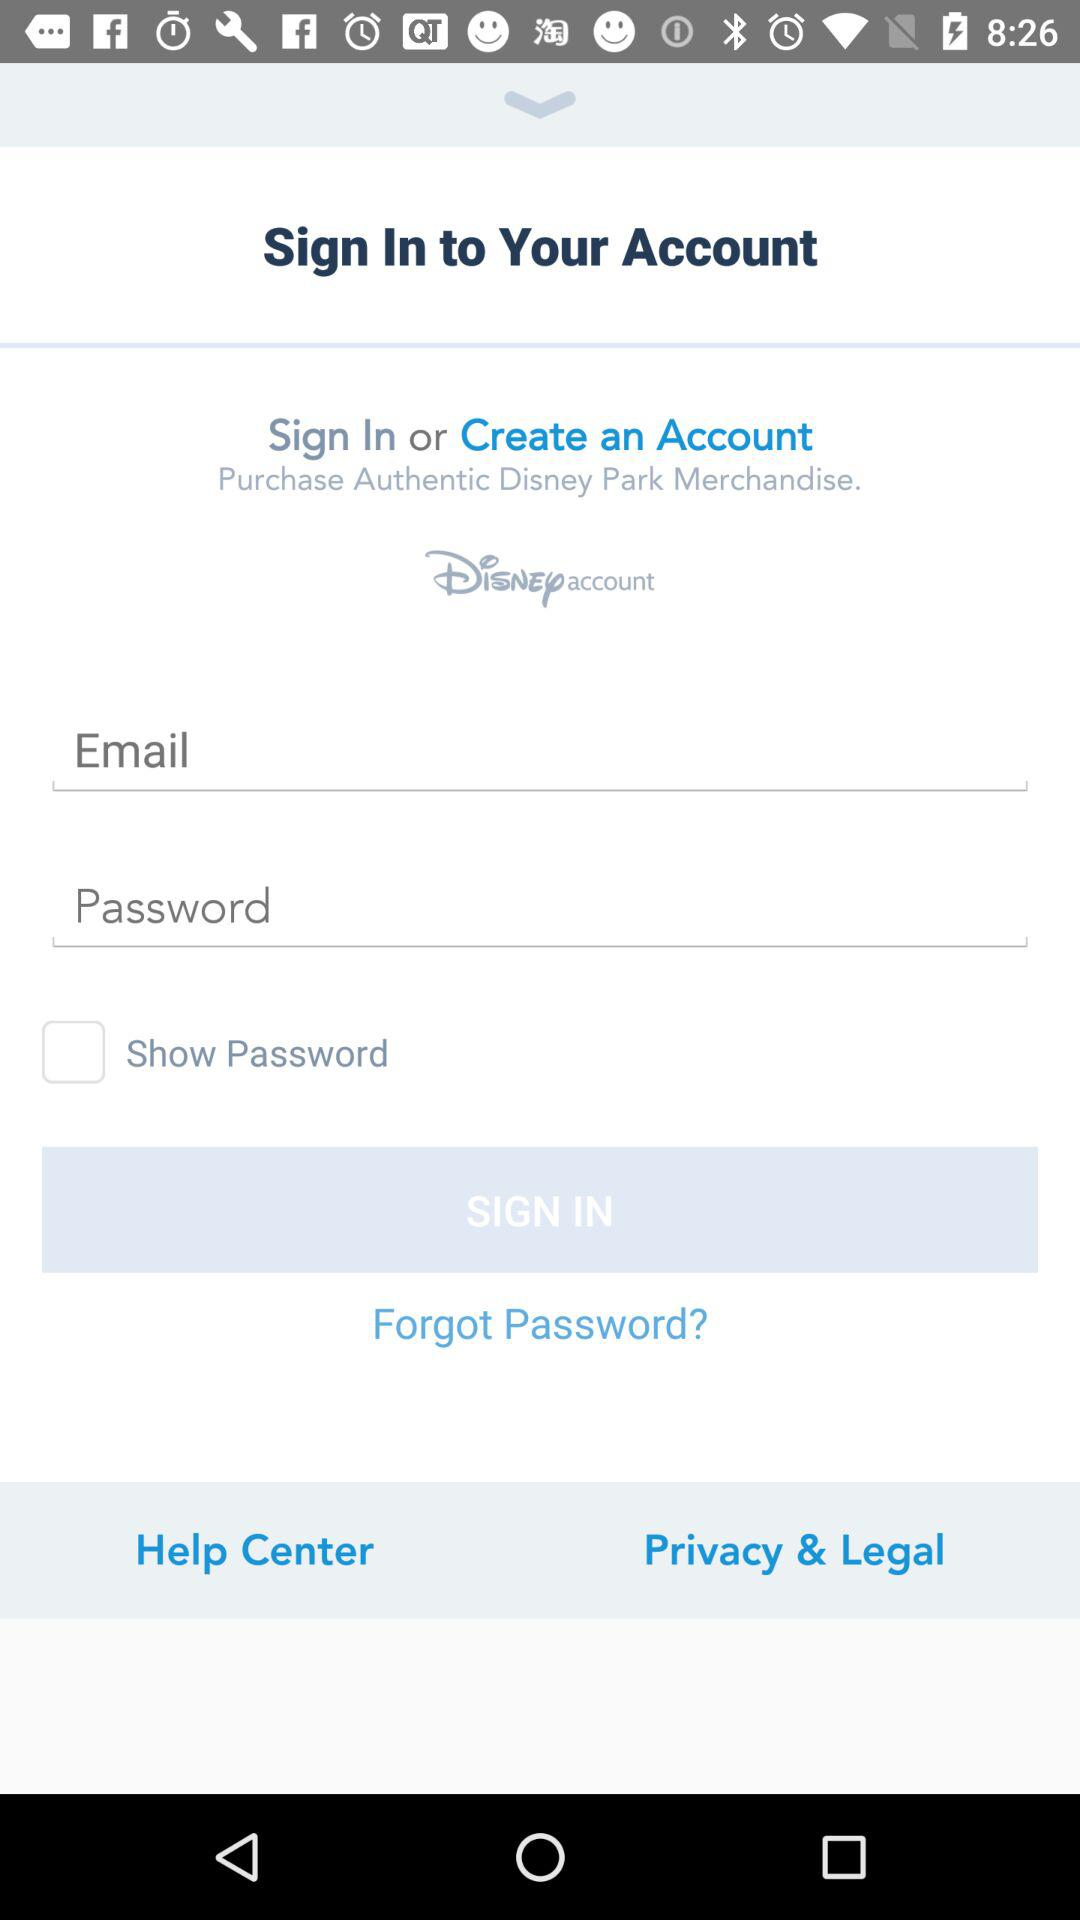What is the status of the "Show Password"? The status of the "Show Password" is "off". 